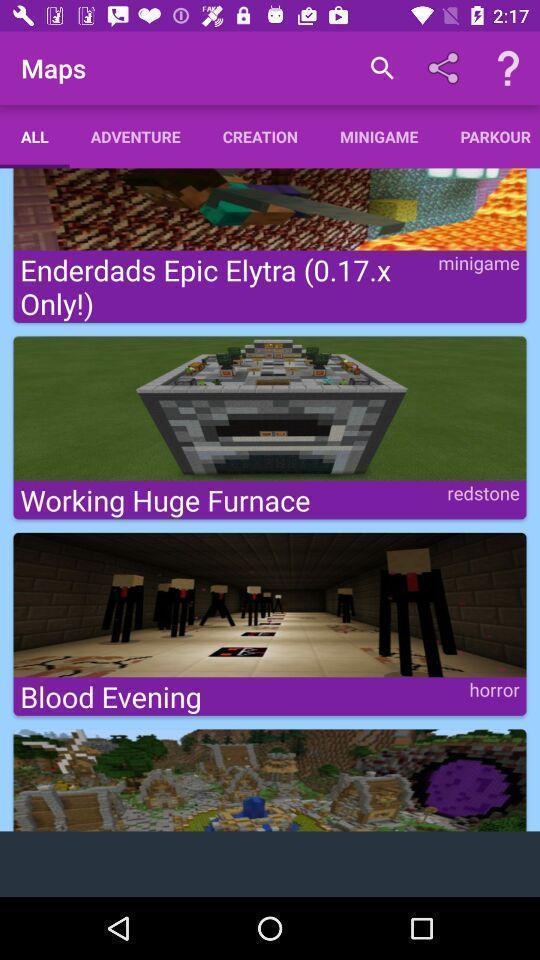Provide a textual representation of this image. Screen page displaying various options. 